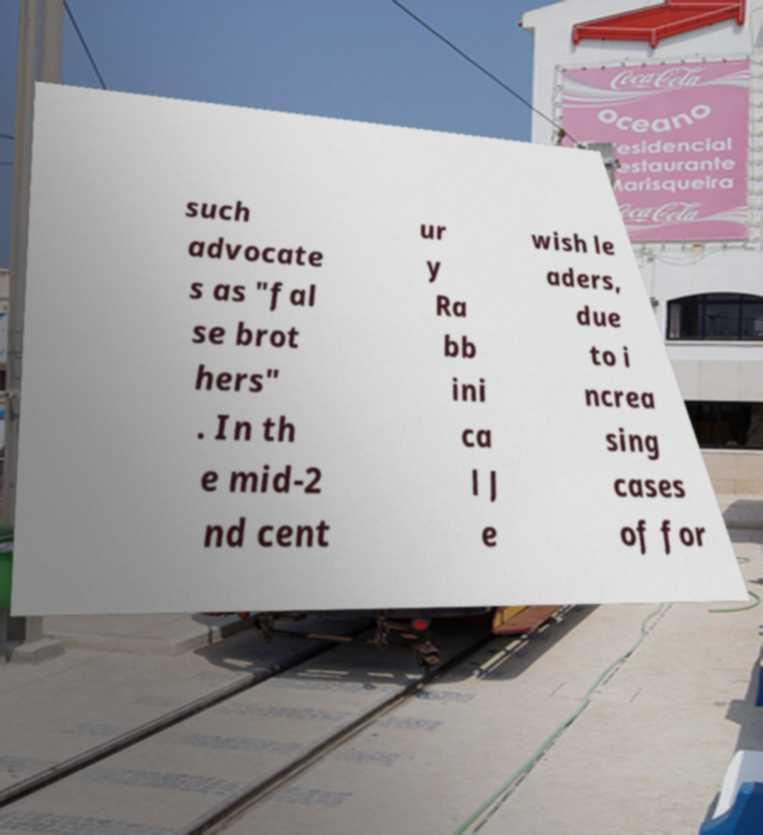Can you read and provide the text displayed in the image?This photo seems to have some interesting text. Can you extract and type it out for me? such advocate s as "fal se brot hers" . In th e mid-2 nd cent ur y Ra bb ini ca l J e wish le aders, due to i ncrea sing cases of for 